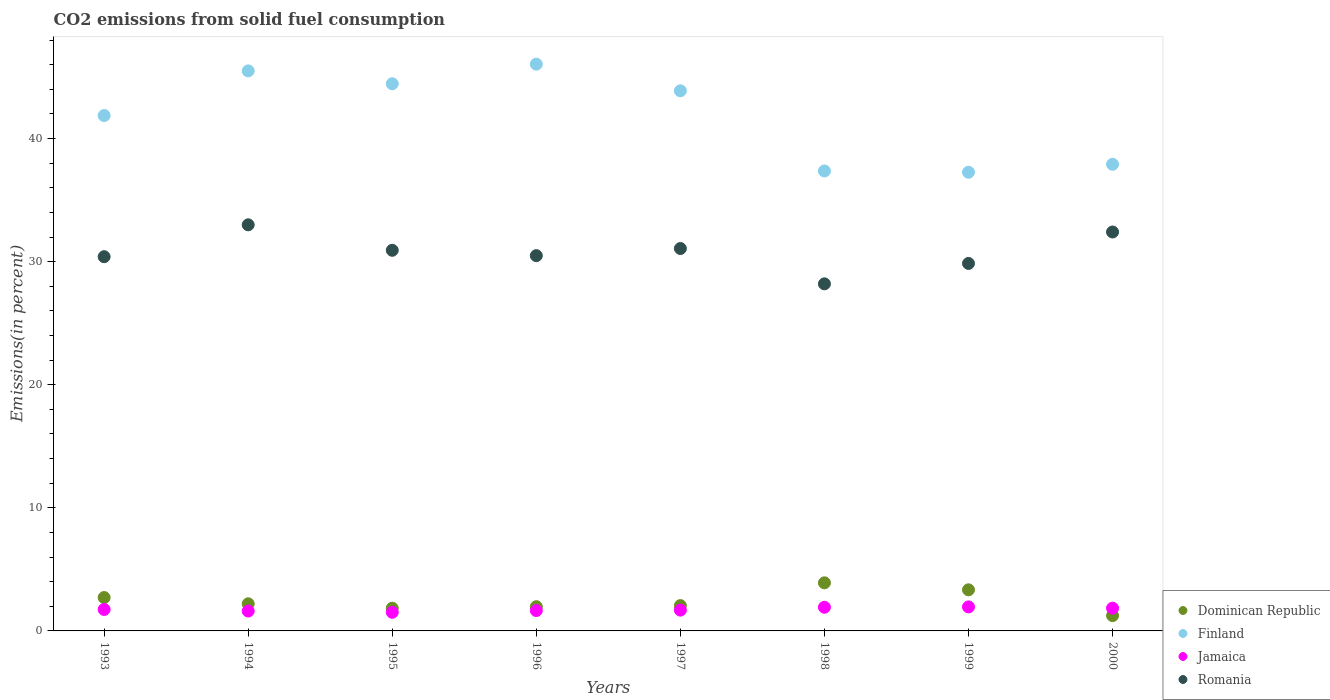What is the total CO2 emitted in Finland in 2000?
Keep it short and to the point. 37.91. Across all years, what is the maximum total CO2 emitted in Dominican Republic?
Your response must be concise. 3.91. Across all years, what is the minimum total CO2 emitted in Jamaica?
Offer a terse response. 1.51. In which year was the total CO2 emitted in Jamaica minimum?
Your answer should be compact. 1995. What is the total total CO2 emitted in Finland in the graph?
Your response must be concise. 334.29. What is the difference between the total CO2 emitted in Finland in 1994 and that in 1996?
Give a very brief answer. -0.55. What is the difference between the total CO2 emitted in Finland in 1993 and the total CO2 emitted in Romania in 1999?
Offer a terse response. 12.01. What is the average total CO2 emitted in Dominican Republic per year?
Provide a short and direct response. 2.41. In the year 1998, what is the difference between the total CO2 emitted in Finland and total CO2 emitted in Jamaica?
Your answer should be very brief. 35.44. In how many years, is the total CO2 emitted in Finland greater than 10 %?
Your response must be concise. 8. What is the ratio of the total CO2 emitted in Finland in 1993 to that in 2000?
Offer a very short reply. 1.1. What is the difference between the highest and the second highest total CO2 emitted in Jamaica?
Your response must be concise. 0.03. What is the difference between the highest and the lowest total CO2 emitted in Dominican Republic?
Your answer should be very brief. 2.67. In how many years, is the total CO2 emitted in Romania greater than the average total CO2 emitted in Romania taken over all years?
Offer a very short reply. 4. Is it the case that in every year, the sum of the total CO2 emitted in Jamaica and total CO2 emitted in Dominican Republic  is greater than the sum of total CO2 emitted in Finland and total CO2 emitted in Romania?
Provide a short and direct response. No. Does the total CO2 emitted in Jamaica monotonically increase over the years?
Provide a short and direct response. No. Is the total CO2 emitted in Jamaica strictly greater than the total CO2 emitted in Finland over the years?
Your answer should be very brief. No. Is the total CO2 emitted in Finland strictly less than the total CO2 emitted in Jamaica over the years?
Your answer should be compact. No. How many years are there in the graph?
Offer a terse response. 8. What is the difference between two consecutive major ticks on the Y-axis?
Keep it short and to the point. 10. Are the values on the major ticks of Y-axis written in scientific E-notation?
Give a very brief answer. No. Does the graph contain any zero values?
Ensure brevity in your answer.  No. Where does the legend appear in the graph?
Your answer should be compact. Bottom right. How many legend labels are there?
Your response must be concise. 4. How are the legend labels stacked?
Keep it short and to the point. Vertical. What is the title of the graph?
Ensure brevity in your answer.  CO2 emissions from solid fuel consumption. What is the label or title of the X-axis?
Offer a very short reply. Years. What is the label or title of the Y-axis?
Your answer should be compact. Emissions(in percent). What is the Emissions(in percent) of Dominican Republic in 1993?
Keep it short and to the point. 2.71. What is the Emissions(in percent) in Finland in 1993?
Offer a terse response. 41.87. What is the Emissions(in percent) of Jamaica in 1993?
Your response must be concise. 1.74. What is the Emissions(in percent) in Romania in 1993?
Provide a succinct answer. 30.4. What is the Emissions(in percent) in Dominican Republic in 1994?
Provide a short and direct response. 2.2. What is the Emissions(in percent) of Finland in 1994?
Your response must be concise. 45.5. What is the Emissions(in percent) in Jamaica in 1994?
Ensure brevity in your answer.  1.61. What is the Emissions(in percent) of Romania in 1994?
Offer a terse response. 32.99. What is the Emissions(in percent) of Dominican Republic in 1995?
Your answer should be very brief. 1.85. What is the Emissions(in percent) in Finland in 1995?
Provide a short and direct response. 44.45. What is the Emissions(in percent) in Jamaica in 1995?
Give a very brief answer. 1.51. What is the Emissions(in percent) in Romania in 1995?
Give a very brief answer. 30.92. What is the Emissions(in percent) of Dominican Republic in 1996?
Keep it short and to the point. 1.97. What is the Emissions(in percent) of Finland in 1996?
Keep it short and to the point. 46.04. What is the Emissions(in percent) of Jamaica in 1996?
Offer a terse response. 1.65. What is the Emissions(in percent) of Romania in 1996?
Your answer should be very brief. 30.49. What is the Emissions(in percent) in Dominican Republic in 1997?
Offer a very short reply. 2.06. What is the Emissions(in percent) in Finland in 1997?
Offer a terse response. 43.88. What is the Emissions(in percent) in Jamaica in 1997?
Make the answer very short. 1.69. What is the Emissions(in percent) in Romania in 1997?
Provide a succinct answer. 31.07. What is the Emissions(in percent) of Dominican Republic in 1998?
Your response must be concise. 3.91. What is the Emissions(in percent) in Finland in 1998?
Offer a terse response. 37.37. What is the Emissions(in percent) of Jamaica in 1998?
Offer a very short reply. 1.92. What is the Emissions(in percent) in Romania in 1998?
Your answer should be very brief. 28.2. What is the Emissions(in percent) in Dominican Republic in 1999?
Your answer should be very brief. 3.34. What is the Emissions(in percent) in Finland in 1999?
Keep it short and to the point. 37.26. What is the Emissions(in percent) in Jamaica in 1999?
Your response must be concise. 1.95. What is the Emissions(in percent) in Romania in 1999?
Your response must be concise. 29.85. What is the Emissions(in percent) in Dominican Republic in 2000?
Offer a very short reply. 1.24. What is the Emissions(in percent) of Finland in 2000?
Offer a very short reply. 37.91. What is the Emissions(in percent) of Jamaica in 2000?
Your response must be concise. 1.85. What is the Emissions(in percent) in Romania in 2000?
Your answer should be very brief. 32.41. Across all years, what is the maximum Emissions(in percent) in Dominican Republic?
Keep it short and to the point. 3.91. Across all years, what is the maximum Emissions(in percent) of Finland?
Ensure brevity in your answer.  46.04. Across all years, what is the maximum Emissions(in percent) in Jamaica?
Make the answer very short. 1.95. Across all years, what is the maximum Emissions(in percent) of Romania?
Make the answer very short. 32.99. Across all years, what is the minimum Emissions(in percent) of Dominican Republic?
Provide a succinct answer. 1.24. Across all years, what is the minimum Emissions(in percent) in Finland?
Your answer should be compact. 37.26. Across all years, what is the minimum Emissions(in percent) in Jamaica?
Give a very brief answer. 1.51. Across all years, what is the minimum Emissions(in percent) in Romania?
Ensure brevity in your answer.  28.2. What is the total Emissions(in percent) of Dominican Republic in the graph?
Provide a succinct answer. 19.28. What is the total Emissions(in percent) in Finland in the graph?
Your answer should be compact. 334.29. What is the total Emissions(in percent) in Jamaica in the graph?
Your answer should be very brief. 13.93. What is the total Emissions(in percent) of Romania in the graph?
Ensure brevity in your answer.  246.33. What is the difference between the Emissions(in percent) in Dominican Republic in 1993 and that in 1994?
Your answer should be compact. 0.51. What is the difference between the Emissions(in percent) in Finland in 1993 and that in 1994?
Provide a short and direct response. -3.63. What is the difference between the Emissions(in percent) in Jamaica in 1993 and that in 1994?
Offer a terse response. 0.13. What is the difference between the Emissions(in percent) in Romania in 1993 and that in 1994?
Ensure brevity in your answer.  -2.59. What is the difference between the Emissions(in percent) of Dominican Republic in 1993 and that in 1995?
Your answer should be compact. 0.87. What is the difference between the Emissions(in percent) in Finland in 1993 and that in 1995?
Offer a terse response. -2.58. What is the difference between the Emissions(in percent) in Jamaica in 1993 and that in 1995?
Make the answer very short. 0.23. What is the difference between the Emissions(in percent) of Romania in 1993 and that in 1995?
Provide a short and direct response. -0.52. What is the difference between the Emissions(in percent) in Dominican Republic in 1993 and that in 1996?
Make the answer very short. 0.74. What is the difference between the Emissions(in percent) in Finland in 1993 and that in 1996?
Give a very brief answer. -4.17. What is the difference between the Emissions(in percent) of Jamaica in 1993 and that in 1996?
Your response must be concise. 0.09. What is the difference between the Emissions(in percent) of Romania in 1993 and that in 1996?
Make the answer very short. -0.08. What is the difference between the Emissions(in percent) in Dominican Republic in 1993 and that in 1997?
Give a very brief answer. 0.65. What is the difference between the Emissions(in percent) of Finland in 1993 and that in 1997?
Give a very brief answer. -2.01. What is the difference between the Emissions(in percent) in Jamaica in 1993 and that in 1997?
Offer a terse response. 0.05. What is the difference between the Emissions(in percent) of Romania in 1993 and that in 1997?
Make the answer very short. -0.66. What is the difference between the Emissions(in percent) in Dominican Republic in 1993 and that in 1998?
Offer a very short reply. -1.19. What is the difference between the Emissions(in percent) in Finland in 1993 and that in 1998?
Your response must be concise. 4.5. What is the difference between the Emissions(in percent) of Jamaica in 1993 and that in 1998?
Provide a succinct answer. -0.18. What is the difference between the Emissions(in percent) of Romania in 1993 and that in 1998?
Make the answer very short. 2.21. What is the difference between the Emissions(in percent) of Dominican Republic in 1993 and that in 1999?
Provide a succinct answer. -0.63. What is the difference between the Emissions(in percent) of Finland in 1993 and that in 1999?
Give a very brief answer. 4.61. What is the difference between the Emissions(in percent) of Jamaica in 1993 and that in 1999?
Your answer should be very brief. -0.21. What is the difference between the Emissions(in percent) of Romania in 1993 and that in 1999?
Keep it short and to the point. 0.55. What is the difference between the Emissions(in percent) in Dominican Republic in 1993 and that in 2000?
Your answer should be very brief. 1.47. What is the difference between the Emissions(in percent) of Finland in 1993 and that in 2000?
Offer a terse response. 3.96. What is the difference between the Emissions(in percent) in Jamaica in 1993 and that in 2000?
Your answer should be compact. -0.1. What is the difference between the Emissions(in percent) in Romania in 1993 and that in 2000?
Give a very brief answer. -2.01. What is the difference between the Emissions(in percent) of Dominican Republic in 1994 and that in 1995?
Your answer should be compact. 0.36. What is the difference between the Emissions(in percent) of Finland in 1994 and that in 1995?
Your answer should be very brief. 1.05. What is the difference between the Emissions(in percent) of Jamaica in 1994 and that in 1995?
Offer a very short reply. 0.1. What is the difference between the Emissions(in percent) of Romania in 1994 and that in 1995?
Your response must be concise. 2.07. What is the difference between the Emissions(in percent) in Dominican Republic in 1994 and that in 1996?
Offer a very short reply. 0.24. What is the difference between the Emissions(in percent) of Finland in 1994 and that in 1996?
Keep it short and to the point. -0.55. What is the difference between the Emissions(in percent) in Jamaica in 1994 and that in 1996?
Your answer should be compact. -0.04. What is the difference between the Emissions(in percent) of Romania in 1994 and that in 1996?
Provide a succinct answer. 2.51. What is the difference between the Emissions(in percent) of Dominican Republic in 1994 and that in 1997?
Provide a succinct answer. 0.15. What is the difference between the Emissions(in percent) of Finland in 1994 and that in 1997?
Your response must be concise. 1.62. What is the difference between the Emissions(in percent) of Jamaica in 1994 and that in 1997?
Give a very brief answer. -0.08. What is the difference between the Emissions(in percent) of Romania in 1994 and that in 1997?
Your answer should be very brief. 1.93. What is the difference between the Emissions(in percent) in Dominican Republic in 1994 and that in 1998?
Provide a short and direct response. -1.7. What is the difference between the Emissions(in percent) of Finland in 1994 and that in 1998?
Your answer should be very brief. 8.13. What is the difference between the Emissions(in percent) in Jamaica in 1994 and that in 1998?
Your answer should be very brief. -0.31. What is the difference between the Emissions(in percent) in Romania in 1994 and that in 1998?
Make the answer very short. 4.8. What is the difference between the Emissions(in percent) of Dominican Republic in 1994 and that in 1999?
Keep it short and to the point. -1.13. What is the difference between the Emissions(in percent) of Finland in 1994 and that in 1999?
Your answer should be compact. 8.23. What is the difference between the Emissions(in percent) in Jamaica in 1994 and that in 1999?
Provide a succinct answer. -0.34. What is the difference between the Emissions(in percent) in Romania in 1994 and that in 1999?
Ensure brevity in your answer.  3.14. What is the difference between the Emissions(in percent) of Dominican Republic in 1994 and that in 2000?
Your response must be concise. 0.96. What is the difference between the Emissions(in percent) of Finland in 1994 and that in 2000?
Offer a very short reply. 7.59. What is the difference between the Emissions(in percent) in Jamaica in 1994 and that in 2000?
Make the answer very short. -0.23. What is the difference between the Emissions(in percent) of Romania in 1994 and that in 2000?
Provide a short and direct response. 0.58. What is the difference between the Emissions(in percent) of Dominican Republic in 1995 and that in 1996?
Provide a short and direct response. -0.12. What is the difference between the Emissions(in percent) of Finland in 1995 and that in 1996?
Offer a terse response. -1.59. What is the difference between the Emissions(in percent) of Jamaica in 1995 and that in 1996?
Give a very brief answer. -0.14. What is the difference between the Emissions(in percent) of Romania in 1995 and that in 1996?
Offer a very short reply. 0.44. What is the difference between the Emissions(in percent) in Dominican Republic in 1995 and that in 1997?
Your response must be concise. -0.21. What is the difference between the Emissions(in percent) of Finland in 1995 and that in 1997?
Offer a very short reply. 0.57. What is the difference between the Emissions(in percent) in Jamaica in 1995 and that in 1997?
Offer a terse response. -0.18. What is the difference between the Emissions(in percent) of Romania in 1995 and that in 1997?
Your answer should be very brief. -0.14. What is the difference between the Emissions(in percent) in Dominican Republic in 1995 and that in 1998?
Give a very brief answer. -2.06. What is the difference between the Emissions(in percent) of Finland in 1995 and that in 1998?
Provide a short and direct response. 7.09. What is the difference between the Emissions(in percent) in Jamaica in 1995 and that in 1998?
Offer a terse response. -0.41. What is the difference between the Emissions(in percent) in Romania in 1995 and that in 1998?
Offer a very short reply. 2.73. What is the difference between the Emissions(in percent) of Dominican Republic in 1995 and that in 1999?
Ensure brevity in your answer.  -1.49. What is the difference between the Emissions(in percent) of Finland in 1995 and that in 1999?
Offer a very short reply. 7.19. What is the difference between the Emissions(in percent) of Jamaica in 1995 and that in 1999?
Make the answer very short. -0.44. What is the difference between the Emissions(in percent) of Romania in 1995 and that in 1999?
Your response must be concise. 1.07. What is the difference between the Emissions(in percent) in Dominican Republic in 1995 and that in 2000?
Keep it short and to the point. 0.61. What is the difference between the Emissions(in percent) in Finland in 1995 and that in 2000?
Ensure brevity in your answer.  6.54. What is the difference between the Emissions(in percent) of Jamaica in 1995 and that in 2000?
Ensure brevity in your answer.  -0.34. What is the difference between the Emissions(in percent) in Romania in 1995 and that in 2000?
Your response must be concise. -1.49. What is the difference between the Emissions(in percent) in Dominican Republic in 1996 and that in 1997?
Offer a terse response. -0.09. What is the difference between the Emissions(in percent) in Finland in 1996 and that in 1997?
Provide a succinct answer. 2.16. What is the difference between the Emissions(in percent) in Jamaica in 1996 and that in 1997?
Give a very brief answer. -0.04. What is the difference between the Emissions(in percent) in Romania in 1996 and that in 1997?
Provide a short and direct response. -0.58. What is the difference between the Emissions(in percent) of Dominican Republic in 1996 and that in 1998?
Ensure brevity in your answer.  -1.94. What is the difference between the Emissions(in percent) of Finland in 1996 and that in 1998?
Give a very brief answer. 8.68. What is the difference between the Emissions(in percent) in Jamaica in 1996 and that in 1998?
Provide a succinct answer. -0.27. What is the difference between the Emissions(in percent) of Romania in 1996 and that in 1998?
Provide a succinct answer. 2.29. What is the difference between the Emissions(in percent) of Dominican Republic in 1996 and that in 1999?
Keep it short and to the point. -1.37. What is the difference between the Emissions(in percent) of Finland in 1996 and that in 1999?
Keep it short and to the point. 8.78. What is the difference between the Emissions(in percent) of Jamaica in 1996 and that in 1999?
Ensure brevity in your answer.  -0.3. What is the difference between the Emissions(in percent) of Romania in 1996 and that in 1999?
Keep it short and to the point. 0.63. What is the difference between the Emissions(in percent) in Dominican Republic in 1996 and that in 2000?
Provide a short and direct response. 0.73. What is the difference between the Emissions(in percent) of Finland in 1996 and that in 2000?
Keep it short and to the point. 8.13. What is the difference between the Emissions(in percent) in Jamaica in 1996 and that in 2000?
Offer a very short reply. -0.19. What is the difference between the Emissions(in percent) in Romania in 1996 and that in 2000?
Offer a very short reply. -1.92. What is the difference between the Emissions(in percent) in Dominican Republic in 1997 and that in 1998?
Provide a short and direct response. -1.85. What is the difference between the Emissions(in percent) in Finland in 1997 and that in 1998?
Your answer should be very brief. 6.52. What is the difference between the Emissions(in percent) in Jamaica in 1997 and that in 1998?
Provide a succinct answer. -0.23. What is the difference between the Emissions(in percent) of Romania in 1997 and that in 1998?
Provide a succinct answer. 2.87. What is the difference between the Emissions(in percent) of Dominican Republic in 1997 and that in 1999?
Keep it short and to the point. -1.28. What is the difference between the Emissions(in percent) of Finland in 1997 and that in 1999?
Offer a terse response. 6.62. What is the difference between the Emissions(in percent) in Jamaica in 1997 and that in 1999?
Offer a terse response. -0.26. What is the difference between the Emissions(in percent) of Romania in 1997 and that in 1999?
Your answer should be very brief. 1.21. What is the difference between the Emissions(in percent) of Dominican Republic in 1997 and that in 2000?
Keep it short and to the point. 0.82. What is the difference between the Emissions(in percent) of Finland in 1997 and that in 2000?
Keep it short and to the point. 5.97. What is the difference between the Emissions(in percent) of Jamaica in 1997 and that in 2000?
Your answer should be compact. -0.16. What is the difference between the Emissions(in percent) of Romania in 1997 and that in 2000?
Provide a succinct answer. -1.34. What is the difference between the Emissions(in percent) in Dominican Republic in 1998 and that in 1999?
Provide a succinct answer. 0.57. What is the difference between the Emissions(in percent) in Finland in 1998 and that in 1999?
Your answer should be compact. 0.1. What is the difference between the Emissions(in percent) in Jamaica in 1998 and that in 1999?
Make the answer very short. -0.03. What is the difference between the Emissions(in percent) in Romania in 1998 and that in 1999?
Provide a short and direct response. -1.66. What is the difference between the Emissions(in percent) in Dominican Republic in 1998 and that in 2000?
Ensure brevity in your answer.  2.67. What is the difference between the Emissions(in percent) in Finland in 1998 and that in 2000?
Your answer should be compact. -0.54. What is the difference between the Emissions(in percent) of Jamaica in 1998 and that in 2000?
Your response must be concise. 0.07. What is the difference between the Emissions(in percent) in Romania in 1998 and that in 2000?
Your answer should be compact. -4.21. What is the difference between the Emissions(in percent) of Dominican Republic in 1999 and that in 2000?
Provide a short and direct response. 2.1. What is the difference between the Emissions(in percent) in Finland in 1999 and that in 2000?
Make the answer very short. -0.65. What is the difference between the Emissions(in percent) of Jamaica in 1999 and that in 2000?
Provide a succinct answer. 0.1. What is the difference between the Emissions(in percent) in Romania in 1999 and that in 2000?
Your answer should be compact. -2.55. What is the difference between the Emissions(in percent) in Dominican Republic in 1993 and the Emissions(in percent) in Finland in 1994?
Your answer should be very brief. -42.79. What is the difference between the Emissions(in percent) of Dominican Republic in 1993 and the Emissions(in percent) of Jamaica in 1994?
Provide a succinct answer. 1.1. What is the difference between the Emissions(in percent) in Dominican Republic in 1993 and the Emissions(in percent) in Romania in 1994?
Offer a terse response. -30.28. What is the difference between the Emissions(in percent) of Finland in 1993 and the Emissions(in percent) of Jamaica in 1994?
Keep it short and to the point. 40.26. What is the difference between the Emissions(in percent) of Finland in 1993 and the Emissions(in percent) of Romania in 1994?
Provide a succinct answer. 8.88. What is the difference between the Emissions(in percent) in Jamaica in 1993 and the Emissions(in percent) in Romania in 1994?
Your answer should be compact. -31.25. What is the difference between the Emissions(in percent) of Dominican Republic in 1993 and the Emissions(in percent) of Finland in 1995?
Provide a short and direct response. -41.74. What is the difference between the Emissions(in percent) in Dominican Republic in 1993 and the Emissions(in percent) in Jamaica in 1995?
Ensure brevity in your answer.  1.2. What is the difference between the Emissions(in percent) in Dominican Republic in 1993 and the Emissions(in percent) in Romania in 1995?
Make the answer very short. -28.21. What is the difference between the Emissions(in percent) in Finland in 1993 and the Emissions(in percent) in Jamaica in 1995?
Offer a terse response. 40.36. What is the difference between the Emissions(in percent) of Finland in 1993 and the Emissions(in percent) of Romania in 1995?
Your answer should be compact. 10.95. What is the difference between the Emissions(in percent) in Jamaica in 1993 and the Emissions(in percent) in Romania in 1995?
Your response must be concise. -29.18. What is the difference between the Emissions(in percent) in Dominican Republic in 1993 and the Emissions(in percent) in Finland in 1996?
Your answer should be very brief. -43.33. What is the difference between the Emissions(in percent) in Dominican Republic in 1993 and the Emissions(in percent) in Jamaica in 1996?
Make the answer very short. 1.06. What is the difference between the Emissions(in percent) in Dominican Republic in 1993 and the Emissions(in percent) in Romania in 1996?
Offer a terse response. -27.78. What is the difference between the Emissions(in percent) in Finland in 1993 and the Emissions(in percent) in Jamaica in 1996?
Keep it short and to the point. 40.22. What is the difference between the Emissions(in percent) in Finland in 1993 and the Emissions(in percent) in Romania in 1996?
Your answer should be very brief. 11.38. What is the difference between the Emissions(in percent) of Jamaica in 1993 and the Emissions(in percent) of Romania in 1996?
Your answer should be very brief. -28.74. What is the difference between the Emissions(in percent) in Dominican Republic in 1993 and the Emissions(in percent) in Finland in 1997?
Keep it short and to the point. -41.17. What is the difference between the Emissions(in percent) of Dominican Republic in 1993 and the Emissions(in percent) of Jamaica in 1997?
Ensure brevity in your answer.  1.02. What is the difference between the Emissions(in percent) of Dominican Republic in 1993 and the Emissions(in percent) of Romania in 1997?
Provide a succinct answer. -28.36. What is the difference between the Emissions(in percent) of Finland in 1993 and the Emissions(in percent) of Jamaica in 1997?
Your answer should be compact. 40.18. What is the difference between the Emissions(in percent) in Finland in 1993 and the Emissions(in percent) in Romania in 1997?
Keep it short and to the point. 10.8. What is the difference between the Emissions(in percent) of Jamaica in 1993 and the Emissions(in percent) of Romania in 1997?
Offer a very short reply. -29.32. What is the difference between the Emissions(in percent) of Dominican Republic in 1993 and the Emissions(in percent) of Finland in 1998?
Make the answer very short. -34.65. What is the difference between the Emissions(in percent) in Dominican Republic in 1993 and the Emissions(in percent) in Jamaica in 1998?
Give a very brief answer. 0.79. What is the difference between the Emissions(in percent) of Dominican Republic in 1993 and the Emissions(in percent) of Romania in 1998?
Give a very brief answer. -25.48. What is the difference between the Emissions(in percent) of Finland in 1993 and the Emissions(in percent) of Jamaica in 1998?
Offer a very short reply. 39.95. What is the difference between the Emissions(in percent) in Finland in 1993 and the Emissions(in percent) in Romania in 1998?
Make the answer very short. 13.67. What is the difference between the Emissions(in percent) in Jamaica in 1993 and the Emissions(in percent) in Romania in 1998?
Provide a short and direct response. -26.45. What is the difference between the Emissions(in percent) of Dominican Republic in 1993 and the Emissions(in percent) of Finland in 1999?
Your answer should be compact. -34.55. What is the difference between the Emissions(in percent) in Dominican Republic in 1993 and the Emissions(in percent) in Jamaica in 1999?
Keep it short and to the point. 0.76. What is the difference between the Emissions(in percent) in Dominican Republic in 1993 and the Emissions(in percent) in Romania in 1999?
Keep it short and to the point. -27.14. What is the difference between the Emissions(in percent) in Finland in 1993 and the Emissions(in percent) in Jamaica in 1999?
Give a very brief answer. 39.92. What is the difference between the Emissions(in percent) of Finland in 1993 and the Emissions(in percent) of Romania in 1999?
Your answer should be compact. 12.02. What is the difference between the Emissions(in percent) in Jamaica in 1993 and the Emissions(in percent) in Romania in 1999?
Give a very brief answer. -28.11. What is the difference between the Emissions(in percent) of Dominican Republic in 1993 and the Emissions(in percent) of Finland in 2000?
Make the answer very short. -35.2. What is the difference between the Emissions(in percent) in Dominican Republic in 1993 and the Emissions(in percent) in Jamaica in 2000?
Offer a very short reply. 0.86. What is the difference between the Emissions(in percent) in Dominican Republic in 1993 and the Emissions(in percent) in Romania in 2000?
Give a very brief answer. -29.7. What is the difference between the Emissions(in percent) of Finland in 1993 and the Emissions(in percent) of Jamaica in 2000?
Your answer should be very brief. 40.02. What is the difference between the Emissions(in percent) of Finland in 1993 and the Emissions(in percent) of Romania in 2000?
Your response must be concise. 9.46. What is the difference between the Emissions(in percent) of Jamaica in 1993 and the Emissions(in percent) of Romania in 2000?
Keep it short and to the point. -30.67. What is the difference between the Emissions(in percent) in Dominican Republic in 1994 and the Emissions(in percent) in Finland in 1995?
Ensure brevity in your answer.  -42.25. What is the difference between the Emissions(in percent) of Dominican Republic in 1994 and the Emissions(in percent) of Jamaica in 1995?
Offer a very short reply. 0.69. What is the difference between the Emissions(in percent) of Dominican Republic in 1994 and the Emissions(in percent) of Romania in 1995?
Offer a very short reply. -28.72. What is the difference between the Emissions(in percent) in Finland in 1994 and the Emissions(in percent) in Jamaica in 1995?
Ensure brevity in your answer.  43.99. What is the difference between the Emissions(in percent) in Finland in 1994 and the Emissions(in percent) in Romania in 1995?
Your answer should be compact. 14.58. What is the difference between the Emissions(in percent) in Jamaica in 1994 and the Emissions(in percent) in Romania in 1995?
Offer a very short reply. -29.31. What is the difference between the Emissions(in percent) in Dominican Republic in 1994 and the Emissions(in percent) in Finland in 1996?
Ensure brevity in your answer.  -43.84. What is the difference between the Emissions(in percent) of Dominican Republic in 1994 and the Emissions(in percent) of Jamaica in 1996?
Keep it short and to the point. 0.55. What is the difference between the Emissions(in percent) of Dominican Republic in 1994 and the Emissions(in percent) of Romania in 1996?
Your response must be concise. -28.28. What is the difference between the Emissions(in percent) in Finland in 1994 and the Emissions(in percent) in Jamaica in 1996?
Your answer should be compact. 43.84. What is the difference between the Emissions(in percent) in Finland in 1994 and the Emissions(in percent) in Romania in 1996?
Offer a very short reply. 15.01. What is the difference between the Emissions(in percent) of Jamaica in 1994 and the Emissions(in percent) of Romania in 1996?
Provide a succinct answer. -28.87. What is the difference between the Emissions(in percent) of Dominican Republic in 1994 and the Emissions(in percent) of Finland in 1997?
Your answer should be compact. -41.68. What is the difference between the Emissions(in percent) of Dominican Republic in 1994 and the Emissions(in percent) of Jamaica in 1997?
Your answer should be very brief. 0.51. What is the difference between the Emissions(in percent) of Dominican Republic in 1994 and the Emissions(in percent) of Romania in 1997?
Provide a succinct answer. -28.86. What is the difference between the Emissions(in percent) in Finland in 1994 and the Emissions(in percent) in Jamaica in 1997?
Offer a terse response. 43.81. What is the difference between the Emissions(in percent) of Finland in 1994 and the Emissions(in percent) of Romania in 1997?
Make the answer very short. 14.43. What is the difference between the Emissions(in percent) of Jamaica in 1994 and the Emissions(in percent) of Romania in 1997?
Your response must be concise. -29.45. What is the difference between the Emissions(in percent) in Dominican Republic in 1994 and the Emissions(in percent) in Finland in 1998?
Make the answer very short. -35.16. What is the difference between the Emissions(in percent) in Dominican Republic in 1994 and the Emissions(in percent) in Jamaica in 1998?
Ensure brevity in your answer.  0.28. What is the difference between the Emissions(in percent) of Dominican Republic in 1994 and the Emissions(in percent) of Romania in 1998?
Give a very brief answer. -25.99. What is the difference between the Emissions(in percent) in Finland in 1994 and the Emissions(in percent) in Jamaica in 1998?
Your answer should be very brief. 43.58. What is the difference between the Emissions(in percent) in Finland in 1994 and the Emissions(in percent) in Romania in 1998?
Make the answer very short. 17.3. What is the difference between the Emissions(in percent) of Jamaica in 1994 and the Emissions(in percent) of Romania in 1998?
Keep it short and to the point. -26.58. What is the difference between the Emissions(in percent) in Dominican Republic in 1994 and the Emissions(in percent) in Finland in 1999?
Make the answer very short. -35.06. What is the difference between the Emissions(in percent) in Dominican Republic in 1994 and the Emissions(in percent) in Jamaica in 1999?
Your answer should be very brief. 0.25. What is the difference between the Emissions(in percent) of Dominican Republic in 1994 and the Emissions(in percent) of Romania in 1999?
Keep it short and to the point. -27.65. What is the difference between the Emissions(in percent) in Finland in 1994 and the Emissions(in percent) in Jamaica in 1999?
Offer a terse response. 43.55. What is the difference between the Emissions(in percent) of Finland in 1994 and the Emissions(in percent) of Romania in 1999?
Keep it short and to the point. 15.64. What is the difference between the Emissions(in percent) of Jamaica in 1994 and the Emissions(in percent) of Romania in 1999?
Provide a short and direct response. -28.24. What is the difference between the Emissions(in percent) of Dominican Republic in 1994 and the Emissions(in percent) of Finland in 2000?
Offer a terse response. -35.71. What is the difference between the Emissions(in percent) of Dominican Republic in 1994 and the Emissions(in percent) of Jamaica in 2000?
Give a very brief answer. 0.36. What is the difference between the Emissions(in percent) of Dominican Republic in 1994 and the Emissions(in percent) of Romania in 2000?
Your answer should be very brief. -30.2. What is the difference between the Emissions(in percent) of Finland in 1994 and the Emissions(in percent) of Jamaica in 2000?
Provide a succinct answer. 43.65. What is the difference between the Emissions(in percent) in Finland in 1994 and the Emissions(in percent) in Romania in 2000?
Offer a terse response. 13.09. What is the difference between the Emissions(in percent) in Jamaica in 1994 and the Emissions(in percent) in Romania in 2000?
Your answer should be compact. -30.8. What is the difference between the Emissions(in percent) of Dominican Republic in 1995 and the Emissions(in percent) of Finland in 1996?
Provide a succinct answer. -44.2. What is the difference between the Emissions(in percent) in Dominican Republic in 1995 and the Emissions(in percent) in Jamaica in 1996?
Ensure brevity in your answer.  0.19. What is the difference between the Emissions(in percent) of Dominican Republic in 1995 and the Emissions(in percent) of Romania in 1996?
Ensure brevity in your answer.  -28.64. What is the difference between the Emissions(in percent) of Finland in 1995 and the Emissions(in percent) of Jamaica in 1996?
Offer a terse response. 42.8. What is the difference between the Emissions(in percent) of Finland in 1995 and the Emissions(in percent) of Romania in 1996?
Keep it short and to the point. 13.96. What is the difference between the Emissions(in percent) of Jamaica in 1995 and the Emissions(in percent) of Romania in 1996?
Your answer should be very brief. -28.98. What is the difference between the Emissions(in percent) in Dominican Republic in 1995 and the Emissions(in percent) in Finland in 1997?
Ensure brevity in your answer.  -42.03. What is the difference between the Emissions(in percent) of Dominican Republic in 1995 and the Emissions(in percent) of Jamaica in 1997?
Offer a very short reply. 0.16. What is the difference between the Emissions(in percent) of Dominican Republic in 1995 and the Emissions(in percent) of Romania in 1997?
Your response must be concise. -29.22. What is the difference between the Emissions(in percent) of Finland in 1995 and the Emissions(in percent) of Jamaica in 1997?
Offer a terse response. 42.76. What is the difference between the Emissions(in percent) of Finland in 1995 and the Emissions(in percent) of Romania in 1997?
Your answer should be compact. 13.39. What is the difference between the Emissions(in percent) of Jamaica in 1995 and the Emissions(in percent) of Romania in 1997?
Your answer should be compact. -29.56. What is the difference between the Emissions(in percent) of Dominican Republic in 1995 and the Emissions(in percent) of Finland in 1998?
Your response must be concise. -35.52. What is the difference between the Emissions(in percent) of Dominican Republic in 1995 and the Emissions(in percent) of Jamaica in 1998?
Your answer should be compact. -0.08. What is the difference between the Emissions(in percent) of Dominican Republic in 1995 and the Emissions(in percent) of Romania in 1998?
Make the answer very short. -26.35. What is the difference between the Emissions(in percent) of Finland in 1995 and the Emissions(in percent) of Jamaica in 1998?
Keep it short and to the point. 42.53. What is the difference between the Emissions(in percent) in Finland in 1995 and the Emissions(in percent) in Romania in 1998?
Your response must be concise. 16.26. What is the difference between the Emissions(in percent) in Jamaica in 1995 and the Emissions(in percent) in Romania in 1998?
Keep it short and to the point. -26.69. What is the difference between the Emissions(in percent) of Dominican Republic in 1995 and the Emissions(in percent) of Finland in 1999?
Provide a short and direct response. -35.42. What is the difference between the Emissions(in percent) in Dominican Republic in 1995 and the Emissions(in percent) in Jamaica in 1999?
Give a very brief answer. -0.1. What is the difference between the Emissions(in percent) in Dominican Republic in 1995 and the Emissions(in percent) in Romania in 1999?
Offer a very short reply. -28.01. What is the difference between the Emissions(in percent) of Finland in 1995 and the Emissions(in percent) of Jamaica in 1999?
Offer a very short reply. 42.5. What is the difference between the Emissions(in percent) in Finland in 1995 and the Emissions(in percent) in Romania in 1999?
Keep it short and to the point. 14.6. What is the difference between the Emissions(in percent) in Jamaica in 1995 and the Emissions(in percent) in Romania in 1999?
Give a very brief answer. -28.34. What is the difference between the Emissions(in percent) of Dominican Republic in 1995 and the Emissions(in percent) of Finland in 2000?
Provide a short and direct response. -36.06. What is the difference between the Emissions(in percent) in Dominican Republic in 1995 and the Emissions(in percent) in Jamaica in 2000?
Provide a short and direct response. -0. What is the difference between the Emissions(in percent) of Dominican Republic in 1995 and the Emissions(in percent) of Romania in 2000?
Keep it short and to the point. -30.56. What is the difference between the Emissions(in percent) of Finland in 1995 and the Emissions(in percent) of Jamaica in 2000?
Ensure brevity in your answer.  42.6. What is the difference between the Emissions(in percent) of Finland in 1995 and the Emissions(in percent) of Romania in 2000?
Provide a short and direct response. 12.04. What is the difference between the Emissions(in percent) of Jamaica in 1995 and the Emissions(in percent) of Romania in 2000?
Give a very brief answer. -30.9. What is the difference between the Emissions(in percent) of Dominican Republic in 1996 and the Emissions(in percent) of Finland in 1997?
Your answer should be very brief. -41.91. What is the difference between the Emissions(in percent) in Dominican Republic in 1996 and the Emissions(in percent) in Jamaica in 1997?
Your answer should be compact. 0.28. What is the difference between the Emissions(in percent) of Dominican Republic in 1996 and the Emissions(in percent) of Romania in 1997?
Make the answer very short. -29.1. What is the difference between the Emissions(in percent) in Finland in 1996 and the Emissions(in percent) in Jamaica in 1997?
Your response must be concise. 44.35. What is the difference between the Emissions(in percent) in Finland in 1996 and the Emissions(in percent) in Romania in 1997?
Offer a terse response. 14.98. What is the difference between the Emissions(in percent) of Jamaica in 1996 and the Emissions(in percent) of Romania in 1997?
Ensure brevity in your answer.  -29.41. What is the difference between the Emissions(in percent) of Dominican Republic in 1996 and the Emissions(in percent) of Finland in 1998?
Offer a terse response. -35.4. What is the difference between the Emissions(in percent) in Dominican Republic in 1996 and the Emissions(in percent) in Jamaica in 1998?
Your response must be concise. 0.05. What is the difference between the Emissions(in percent) in Dominican Republic in 1996 and the Emissions(in percent) in Romania in 1998?
Give a very brief answer. -26.23. What is the difference between the Emissions(in percent) in Finland in 1996 and the Emissions(in percent) in Jamaica in 1998?
Offer a terse response. 44.12. What is the difference between the Emissions(in percent) in Finland in 1996 and the Emissions(in percent) in Romania in 1998?
Your response must be concise. 17.85. What is the difference between the Emissions(in percent) of Jamaica in 1996 and the Emissions(in percent) of Romania in 1998?
Provide a short and direct response. -26.54. What is the difference between the Emissions(in percent) of Dominican Republic in 1996 and the Emissions(in percent) of Finland in 1999?
Give a very brief answer. -35.3. What is the difference between the Emissions(in percent) of Dominican Republic in 1996 and the Emissions(in percent) of Jamaica in 1999?
Ensure brevity in your answer.  0.02. What is the difference between the Emissions(in percent) of Dominican Republic in 1996 and the Emissions(in percent) of Romania in 1999?
Provide a short and direct response. -27.89. What is the difference between the Emissions(in percent) in Finland in 1996 and the Emissions(in percent) in Jamaica in 1999?
Ensure brevity in your answer.  44.09. What is the difference between the Emissions(in percent) in Finland in 1996 and the Emissions(in percent) in Romania in 1999?
Ensure brevity in your answer.  16.19. What is the difference between the Emissions(in percent) of Jamaica in 1996 and the Emissions(in percent) of Romania in 1999?
Make the answer very short. -28.2. What is the difference between the Emissions(in percent) in Dominican Republic in 1996 and the Emissions(in percent) in Finland in 2000?
Your answer should be very brief. -35.94. What is the difference between the Emissions(in percent) in Dominican Republic in 1996 and the Emissions(in percent) in Jamaica in 2000?
Provide a short and direct response. 0.12. What is the difference between the Emissions(in percent) in Dominican Republic in 1996 and the Emissions(in percent) in Romania in 2000?
Your answer should be compact. -30.44. What is the difference between the Emissions(in percent) of Finland in 1996 and the Emissions(in percent) of Jamaica in 2000?
Provide a short and direct response. 44.2. What is the difference between the Emissions(in percent) of Finland in 1996 and the Emissions(in percent) of Romania in 2000?
Ensure brevity in your answer.  13.64. What is the difference between the Emissions(in percent) in Jamaica in 1996 and the Emissions(in percent) in Romania in 2000?
Your response must be concise. -30.76. What is the difference between the Emissions(in percent) of Dominican Republic in 1997 and the Emissions(in percent) of Finland in 1998?
Your response must be concise. -35.31. What is the difference between the Emissions(in percent) in Dominican Republic in 1997 and the Emissions(in percent) in Jamaica in 1998?
Your response must be concise. 0.14. What is the difference between the Emissions(in percent) of Dominican Republic in 1997 and the Emissions(in percent) of Romania in 1998?
Provide a succinct answer. -26.14. What is the difference between the Emissions(in percent) of Finland in 1997 and the Emissions(in percent) of Jamaica in 1998?
Your response must be concise. 41.96. What is the difference between the Emissions(in percent) of Finland in 1997 and the Emissions(in percent) of Romania in 1998?
Provide a succinct answer. 15.68. What is the difference between the Emissions(in percent) of Jamaica in 1997 and the Emissions(in percent) of Romania in 1998?
Keep it short and to the point. -26.51. What is the difference between the Emissions(in percent) of Dominican Republic in 1997 and the Emissions(in percent) of Finland in 1999?
Keep it short and to the point. -35.21. What is the difference between the Emissions(in percent) of Dominican Republic in 1997 and the Emissions(in percent) of Jamaica in 1999?
Provide a short and direct response. 0.11. What is the difference between the Emissions(in percent) in Dominican Republic in 1997 and the Emissions(in percent) in Romania in 1999?
Your response must be concise. -27.8. What is the difference between the Emissions(in percent) in Finland in 1997 and the Emissions(in percent) in Jamaica in 1999?
Provide a succinct answer. 41.93. What is the difference between the Emissions(in percent) of Finland in 1997 and the Emissions(in percent) of Romania in 1999?
Your answer should be compact. 14.03. What is the difference between the Emissions(in percent) in Jamaica in 1997 and the Emissions(in percent) in Romania in 1999?
Provide a succinct answer. -28.16. What is the difference between the Emissions(in percent) of Dominican Republic in 1997 and the Emissions(in percent) of Finland in 2000?
Your answer should be very brief. -35.85. What is the difference between the Emissions(in percent) of Dominican Republic in 1997 and the Emissions(in percent) of Jamaica in 2000?
Your answer should be compact. 0.21. What is the difference between the Emissions(in percent) of Dominican Republic in 1997 and the Emissions(in percent) of Romania in 2000?
Give a very brief answer. -30.35. What is the difference between the Emissions(in percent) of Finland in 1997 and the Emissions(in percent) of Jamaica in 2000?
Ensure brevity in your answer.  42.03. What is the difference between the Emissions(in percent) of Finland in 1997 and the Emissions(in percent) of Romania in 2000?
Your response must be concise. 11.47. What is the difference between the Emissions(in percent) of Jamaica in 1997 and the Emissions(in percent) of Romania in 2000?
Your answer should be compact. -30.72. What is the difference between the Emissions(in percent) in Dominican Republic in 1998 and the Emissions(in percent) in Finland in 1999?
Your answer should be compact. -33.36. What is the difference between the Emissions(in percent) of Dominican Republic in 1998 and the Emissions(in percent) of Jamaica in 1999?
Provide a succinct answer. 1.96. What is the difference between the Emissions(in percent) of Dominican Republic in 1998 and the Emissions(in percent) of Romania in 1999?
Provide a short and direct response. -25.95. What is the difference between the Emissions(in percent) of Finland in 1998 and the Emissions(in percent) of Jamaica in 1999?
Your answer should be compact. 35.41. What is the difference between the Emissions(in percent) in Finland in 1998 and the Emissions(in percent) in Romania in 1999?
Your response must be concise. 7.51. What is the difference between the Emissions(in percent) in Jamaica in 1998 and the Emissions(in percent) in Romania in 1999?
Ensure brevity in your answer.  -27.93. What is the difference between the Emissions(in percent) in Dominican Republic in 1998 and the Emissions(in percent) in Finland in 2000?
Give a very brief answer. -34. What is the difference between the Emissions(in percent) in Dominican Republic in 1998 and the Emissions(in percent) in Jamaica in 2000?
Provide a succinct answer. 2.06. What is the difference between the Emissions(in percent) of Dominican Republic in 1998 and the Emissions(in percent) of Romania in 2000?
Offer a terse response. -28.5. What is the difference between the Emissions(in percent) of Finland in 1998 and the Emissions(in percent) of Jamaica in 2000?
Offer a very short reply. 35.52. What is the difference between the Emissions(in percent) of Finland in 1998 and the Emissions(in percent) of Romania in 2000?
Your answer should be very brief. 4.96. What is the difference between the Emissions(in percent) in Jamaica in 1998 and the Emissions(in percent) in Romania in 2000?
Keep it short and to the point. -30.49. What is the difference between the Emissions(in percent) in Dominican Republic in 1999 and the Emissions(in percent) in Finland in 2000?
Your answer should be compact. -34.57. What is the difference between the Emissions(in percent) of Dominican Republic in 1999 and the Emissions(in percent) of Jamaica in 2000?
Your answer should be very brief. 1.49. What is the difference between the Emissions(in percent) in Dominican Republic in 1999 and the Emissions(in percent) in Romania in 2000?
Your answer should be compact. -29.07. What is the difference between the Emissions(in percent) of Finland in 1999 and the Emissions(in percent) of Jamaica in 2000?
Keep it short and to the point. 35.42. What is the difference between the Emissions(in percent) of Finland in 1999 and the Emissions(in percent) of Romania in 2000?
Give a very brief answer. 4.85. What is the difference between the Emissions(in percent) of Jamaica in 1999 and the Emissions(in percent) of Romania in 2000?
Give a very brief answer. -30.46. What is the average Emissions(in percent) of Dominican Republic per year?
Ensure brevity in your answer.  2.41. What is the average Emissions(in percent) of Finland per year?
Give a very brief answer. 41.79. What is the average Emissions(in percent) in Jamaica per year?
Keep it short and to the point. 1.74. What is the average Emissions(in percent) in Romania per year?
Offer a very short reply. 30.79. In the year 1993, what is the difference between the Emissions(in percent) in Dominican Republic and Emissions(in percent) in Finland?
Keep it short and to the point. -39.16. In the year 1993, what is the difference between the Emissions(in percent) in Dominican Republic and Emissions(in percent) in Jamaica?
Give a very brief answer. 0.97. In the year 1993, what is the difference between the Emissions(in percent) of Dominican Republic and Emissions(in percent) of Romania?
Provide a short and direct response. -27.69. In the year 1993, what is the difference between the Emissions(in percent) in Finland and Emissions(in percent) in Jamaica?
Your answer should be compact. 40.13. In the year 1993, what is the difference between the Emissions(in percent) in Finland and Emissions(in percent) in Romania?
Offer a very short reply. 11.47. In the year 1993, what is the difference between the Emissions(in percent) of Jamaica and Emissions(in percent) of Romania?
Offer a very short reply. -28.66. In the year 1994, what is the difference between the Emissions(in percent) of Dominican Republic and Emissions(in percent) of Finland?
Offer a terse response. -43.29. In the year 1994, what is the difference between the Emissions(in percent) of Dominican Republic and Emissions(in percent) of Jamaica?
Provide a short and direct response. 0.59. In the year 1994, what is the difference between the Emissions(in percent) in Dominican Republic and Emissions(in percent) in Romania?
Give a very brief answer. -30.79. In the year 1994, what is the difference between the Emissions(in percent) in Finland and Emissions(in percent) in Jamaica?
Provide a succinct answer. 43.88. In the year 1994, what is the difference between the Emissions(in percent) in Finland and Emissions(in percent) in Romania?
Your answer should be compact. 12.51. In the year 1994, what is the difference between the Emissions(in percent) in Jamaica and Emissions(in percent) in Romania?
Your response must be concise. -31.38. In the year 1995, what is the difference between the Emissions(in percent) of Dominican Republic and Emissions(in percent) of Finland?
Offer a very short reply. -42.61. In the year 1995, what is the difference between the Emissions(in percent) in Dominican Republic and Emissions(in percent) in Jamaica?
Make the answer very short. 0.34. In the year 1995, what is the difference between the Emissions(in percent) in Dominican Republic and Emissions(in percent) in Romania?
Give a very brief answer. -29.08. In the year 1995, what is the difference between the Emissions(in percent) in Finland and Emissions(in percent) in Jamaica?
Ensure brevity in your answer.  42.94. In the year 1995, what is the difference between the Emissions(in percent) of Finland and Emissions(in percent) of Romania?
Your response must be concise. 13.53. In the year 1995, what is the difference between the Emissions(in percent) of Jamaica and Emissions(in percent) of Romania?
Provide a short and direct response. -29.41. In the year 1996, what is the difference between the Emissions(in percent) of Dominican Republic and Emissions(in percent) of Finland?
Ensure brevity in your answer.  -44.08. In the year 1996, what is the difference between the Emissions(in percent) of Dominican Republic and Emissions(in percent) of Jamaica?
Your answer should be compact. 0.31. In the year 1996, what is the difference between the Emissions(in percent) in Dominican Republic and Emissions(in percent) in Romania?
Give a very brief answer. -28.52. In the year 1996, what is the difference between the Emissions(in percent) of Finland and Emissions(in percent) of Jamaica?
Offer a very short reply. 44.39. In the year 1996, what is the difference between the Emissions(in percent) of Finland and Emissions(in percent) of Romania?
Your answer should be compact. 15.56. In the year 1996, what is the difference between the Emissions(in percent) of Jamaica and Emissions(in percent) of Romania?
Your response must be concise. -28.83. In the year 1997, what is the difference between the Emissions(in percent) of Dominican Republic and Emissions(in percent) of Finland?
Your answer should be very brief. -41.82. In the year 1997, what is the difference between the Emissions(in percent) in Dominican Republic and Emissions(in percent) in Jamaica?
Offer a very short reply. 0.37. In the year 1997, what is the difference between the Emissions(in percent) in Dominican Republic and Emissions(in percent) in Romania?
Your answer should be very brief. -29.01. In the year 1997, what is the difference between the Emissions(in percent) of Finland and Emissions(in percent) of Jamaica?
Offer a terse response. 42.19. In the year 1997, what is the difference between the Emissions(in percent) of Finland and Emissions(in percent) of Romania?
Provide a succinct answer. 12.81. In the year 1997, what is the difference between the Emissions(in percent) in Jamaica and Emissions(in percent) in Romania?
Give a very brief answer. -29.38. In the year 1998, what is the difference between the Emissions(in percent) of Dominican Republic and Emissions(in percent) of Finland?
Your answer should be compact. -33.46. In the year 1998, what is the difference between the Emissions(in percent) of Dominican Republic and Emissions(in percent) of Jamaica?
Your answer should be very brief. 1.98. In the year 1998, what is the difference between the Emissions(in percent) in Dominican Republic and Emissions(in percent) in Romania?
Ensure brevity in your answer.  -24.29. In the year 1998, what is the difference between the Emissions(in percent) in Finland and Emissions(in percent) in Jamaica?
Ensure brevity in your answer.  35.44. In the year 1998, what is the difference between the Emissions(in percent) in Finland and Emissions(in percent) in Romania?
Provide a succinct answer. 9.17. In the year 1998, what is the difference between the Emissions(in percent) of Jamaica and Emissions(in percent) of Romania?
Keep it short and to the point. -26.27. In the year 1999, what is the difference between the Emissions(in percent) in Dominican Republic and Emissions(in percent) in Finland?
Give a very brief answer. -33.92. In the year 1999, what is the difference between the Emissions(in percent) of Dominican Republic and Emissions(in percent) of Jamaica?
Give a very brief answer. 1.39. In the year 1999, what is the difference between the Emissions(in percent) in Dominican Republic and Emissions(in percent) in Romania?
Provide a short and direct response. -26.52. In the year 1999, what is the difference between the Emissions(in percent) of Finland and Emissions(in percent) of Jamaica?
Give a very brief answer. 35.31. In the year 1999, what is the difference between the Emissions(in percent) of Finland and Emissions(in percent) of Romania?
Your answer should be very brief. 7.41. In the year 1999, what is the difference between the Emissions(in percent) in Jamaica and Emissions(in percent) in Romania?
Provide a short and direct response. -27.9. In the year 2000, what is the difference between the Emissions(in percent) in Dominican Republic and Emissions(in percent) in Finland?
Provide a short and direct response. -36.67. In the year 2000, what is the difference between the Emissions(in percent) of Dominican Republic and Emissions(in percent) of Jamaica?
Your answer should be compact. -0.61. In the year 2000, what is the difference between the Emissions(in percent) of Dominican Republic and Emissions(in percent) of Romania?
Give a very brief answer. -31.17. In the year 2000, what is the difference between the Emissions(in percent) of Finland and Emissions(in percent) of Jamaica?
Provide a succinct answer. 36.06. In the year 2000, what is the difference between the Emissions(in percent) of Finland and Emissions(in percent) of Romania?
Your answer should be compact. 5.5. In the year 2000, what is the difference between the Emissions(in percent) of Jamaica and Emissions(in percent) of Romania?
Give a very brief answer. -30.56. What is the ratio of the Emissions(in percent) in Dominican Republic in 1993 to that in 1994?
Make the answer very short. 1.23. What is the ratio of the Emissions(in percent) in Finland in 1993 to that in 1994?
Make the answer very short. 0.92. What is the ratio of the Emissions(in percent) in Jamaica in 1993 to that in 1994?
Give a very brief answer. 1.08. What is the ratio of the Emissions(in percent) of Romania in 1993 to that in 1994?
Make the answer very short. 0.92. What is the ratio of the Emissions(in percent) of Dominican Republic in 1993 to that in 1995?
Your response must be concise. 1.47. What is the ratio of the Emissions(in percent) in Finland in 1993 to that in 1995?
Make the answer very short. 0.94. What is the ratio of the Emissions(in percent) of Jamaica in 1993 to that in 1995?
Offer a very short reply. 1.15. What is the ratio of the Emissions(in percent) in Romania in 1993 to that in 1995?
Your answer should be very brief. 0.98. What is the ratio of the Emissions(in percent) of Dominican Republic in 1993 to that in 1996?
Offer a terse response. 1.38. What is the ratio of the Emissions(in percent) in Finland in 1993 to that in 1996?
Ensure brevity in your answer.  0.91. What is the ratio of the Emissions(in percent) of Jamaica in 1993 to that in 1996?
Keep it short and to the point. 1.05. What is the ratio of the Emissions(in percent) in Dominican Republic in 1993 to that in 1997?
Make the answer very short. 1.32. What is the ratio of the Emissions(in percent) in Finland in 1993 to that in 1997?
Give a very brief answer. 0.95. What is the ratio of the Emissions(in percent) in Jamaica in 1993 to that in 1997?
Make the answer very short. 1.03. What is the ratio of the Emissions(in percent) in Romania in 1993 to that in 1997?
Make the answer very short. 0.98. What is the ratio of the Emissions(in percent) in Dominican Republic in 1993 to that in 1998?
Provide a short and direct response. 0.69. What is the ratio of the Emissions(in percent) of Finland in 1993 to that in 1998?
Offer a terse response. 1.12. What is the ratio of the Emissions(in percent) in Jamaica in 1993 to that in 1998?
Offer a terse response. 0.91. What is the ratio of the Emissions(in percent) of Romania in 1993 to that in 1998?
Your answer should be very brief. 1.08. What is the ratio of the Emissions(in percent) of Dominican Republic in 1993 to that in 1999?
Provide a succinct answer. 0.81. What is the ratio of the Emissions(in percent) of Finland in 1993 to that in 1999?
Ensure brevity in your answer.  1.12. What is the ratio of the Emissions(in percent) of Jamaica in 1993 to that in 1999?
Your answer should be very brief. 0.89. What is the ratio of the Emissions(in percent) of Romania in 1993 to that in 1999?
Your response must be concise. 1.02. What is the ratio of the Emissions(in percent) in Dominican Republic in 1993 to that in 2000?
Offer a very short reply. 2.18. What is the ratio of the Emissions(in percent) of Finland in 1993 to that in 2000?
Give a very brief answer. 1.1. What is the ratio of the Emissions(in percent) in Jamaica in 1993 to that in 2000?
Offer a very short reply. 0.94. What is the ratio of the Emissions(in percent) of Romania in 1993 to that in 2000?
Your response must be concise. 0.94. What is the ratio of the Emissions(in percent) in Dominican Republic in 1994 to that in 1995?
Your answer should be compact. 1.19. What is the ratio of the Emissions(in percent) of Finland in 1994 to that in 1995?
Provide a short and direct response. 1.02. What is the ratio of the Emissions(in percent) in Jamaica in 1994 to that in 1995?
Your answer should be very brief. 1.07. What is the ratio of the Emissions(in percent) of Romania in 1994 to that in 1995?
Offer a terse response. 1.07. What is the ratio of the Emissions(in percent) in Dominican Republic in 1994 to that in 1996?
Your answer should be very brief. 1.12. What is the ratio of the Emissions(in percent) in Jamaica in 1994 to that in 1996?
Provide a succinct answer. 0.98. What is the ratio of the Emissions(in percent) of Romania in 1994 to that in 1996?
Provide a short and direct response. 1.08. What is the ratio of the Emissions(in percent) of Dominican Republic in 1994 to that in 1997?
Keep it short and to the point. 1.07. What is the ratio of the Emissions(in percent) in Finland in 1994 to that in 1997?
Keep it short and to the point. 1.04. What is the ratio of the Emissions(in percent) in Jamaica in 1994 to that in 1997?
Offer a very short reply. 0.96. What is the ratio of the Emissions(in percent) of Romania in 1994 to that in 1997?
Ensure brevity in your answer.  1.06. What is the ratio of the Emissions(in percent) of Dominican Republic in 1994 to that in 1998?
Give a very brief answer. 0.56. What is the ratio of the Emissions(in percent) in Finland in 1994 to that in 1998?
Provide a short and direct response. 1.22. What is the ratio of the Emissions(in percent) in Jamaica in 1994 to that in 1998?
Your answer should be compact. 0.84. What is the ratio of the Emissions(in percent) in Romania in 1994 to that in 1998?
Provide a succinct answer. 1.17. What is the ratio of the Emissions(in percent) in Dominican Republic in 1994 to that in 1999?
Offer a very short reply. 0.66. What is the ratio of the Emissions(in percent) in Finland in 1994 to that in 1999?
Your answer should be compact. 1.22. What is the ratio of the Emissions(in percent) in Jamaica in 1994 to that in 1999?
Ensure brevity in your answer.  0.83. What is the ratio of the Emissions(in percent) in Romania in 1994 to that in 1999?
Your answer should be very brief. 1.11. What is the ratio of the Emissions(in percent) of Dominican Republic in 1994 to that in 2000?
Provide a succinct answer. 1.78. What is the ratio of the Emissions(in percent) of Finland in 1994 to that in 2000?
Your response must be concise. 1.2. What is the ratio of the Emissions(in percent) in Jamaica in 1994 to that in 2000?
Provide a succinct answer. 0.87. What is the ratio of the Emissions(in percent) in Romania in 1994 to that in 2000?
Ensure brevity in your answer.  1.02. What is the ratio of the Emissions(in percent) of Dominican Republic in 1995 to that in 1996?
Your answer should be very brief. 0.94. What is the ratio of the Emissions(in percent) in Finland in 1995 to that in 1996?
Provide a short and direct response. 0.97. What is the ratio of the Emissions(in percent) of Jamaica in 1995 to that in 1996?
Your response must be concise. 0.91. What is the ratio of the Emissions(in percent) of Romania in 1995 to that in 1996?
Give a very brief answer. 1.01. What is the ratio of the Emissions(in percent) in Dominican Republic in 1995 to that in 1997?
Give a very brief answer. 0.9. What is the ratio of the Emissions(in percent) in Finland in 1995 to that in 1997?
Your answer should be very brief. 1.01. What is the ratio of the Emissions(in percent) in Jamaica in 1995 to that in 1997?
Your answer should be compact. 0.89. What is the ratio of the Emissions(in percent) of Dominican Republic in 1995 to that in 1998?
Provide a short and direct response. 0.47. What is the ratio of the Emissions(in percent) of Finland in 1995 to that in 1998?
Give a very brief answer. 1.19. What is the ratio of the Emissions(in percent) in Jamaica in 1995 to that in 1998?
Make the answer very short. 0.79. What is the ratio of the Emissions(in percent) of Romania in 1995 to that in 1998?
Make the answer very short. 1.1. What is the ratio of the Emissions(in percent) in Dominican Republic in 1995 to that in 1999?
Offer a terse response. 0.55. What is the ratio of the Emissions(in percent) of Finland in 1995 to that in 1999?
Your answer should be very brief. 1.19. What is the ratio of the Emissions(in percent) in Jamaica in 1995 to that in 1999?
Offer a very short reply. 0.77. What is the ratio of the Emissions(in percent) in Romania in 1995 to that in 1999?
Your answer should be very brief. 1.04. What is the ratio of the Emissions(in percent) of Dominican Republic in 1995 to that in 2000?
Give a very brief answer. 1.49. What is the ratio of the Emissions(in percent) in Finland in 1995 to that in 2000?
Offer a very short reply. 1.17. What is the ratio of the Emissions(in percent) of Jamaica in 1995 to that in 2000?
Your response must be concise. 0.82. What is the ratio of the Emissions(in percent) in Romania in 1995 to that in 2000?
Your response must be concise. 0.95. What is the ratio of the Emissions(in percent) in Dominican Republic in 1996 to that in 1997?
Make the answer very short. 0.96. What is the ratio of the Emissions(in percent) in Finland in 1996 to that in 1997?
Offer a terse response. 1.05. What is the ratio of the Emissions(in percent) in Jamaica in 1996 to that in 1997?
Your answer should be compact. 0.98. What is the ratio of the Emissions(in percent) in Romania in 1996 to that in 1997?
Provide a short and direct response. 0.98. What is the ratio of the Emissions(in percent) of Dominican Republic in 1996 to that in 1998?
Your answer should be very brief. 0.5. What is the ratio of the Emissions(in percent) of Finland in 1996 to that in 1998?
Keep it short and to the point. 1.23. What is the ratio of the Emissions(in percent) in Jamaica in 1996 to that in 1998?
Offer a terse response. 0.86. What is the ratio of the Emissions(in percent) in Romania in 1996 to that in 1998?
Your answer should be compact. 1.08. What is the ratio of the Emissions(in percent) in Dominican Republic in 1996 to that in 1999?
Your answer should be very brief. 0.59. What is the ratio of the Emissions(in percent) of Finland in 1996 to that in 1999?
Ensure brevity in your answer.  1.24. What is the ratio of the Emissions(in percent) in Jamaica in 1996 to that in 1999?
Your response must be concise. 0.85. What is the ratio of the Emissions(in percent) of Romania in 1996 to that in 1999?
Keep it short and to the point. 1.02. What is the ratio of the Emissions(in percent) in Dominican Republic in 1996 to that in 2000?
Offer a terse response. 1.59. What is the ratio of the Emissions(in percent) of Finland in 1996 to that in 2000?
Provide a short and direct response. 1.21. What is the ratio of the Emissions(in percent) in Jamaica in 1996 to that in 2000?
Your answer should be compact. 0.9. What is the ratio of the Emissions(in percent) in Romania in 1996 to that in 2000?
Your response must be concise. 0.94. What is the ratio of the Emissions(in percent) in Dominican Republic in 1997 to that in 1998?
Your answer should be very brief. 0.53. What is the ratio of the Emissions(in percent) of Finland in 1997 to that in 1998?
Your answer should be compact. 1.17. What is the ratio of the Emissions(in percent) of Jamaica in 1997 to that in 1998?
Your answer should be very brief. 0.88. What is the ratio of the Emissions(in percent) in Romania in 1997 to that in 1998?
Your answer should be very brief. 1.1. What is the ratio of the Emissions(in percent) of Dominican Republic in 1997 to that in 1999?
Offer a very short reply. 0.62. What is the ratio of the Emissions(in percent) in Finland in 1997 to that in 1999?
Offer a terse response. 1.18. What is the ratio of the Emissions(in percent) of Jamaica in 1997 to that in 1999?
Provide a succinct answer. 0.87. What is the ratio of the Emissions(in percent) in Romania in 1997 to that in 1999?
Make the answer very short. 1.04. What is the ratio of the Emissions(in percent) of Dominican Republic in 1997 to that in 2000?
Keep it short and to the point. 1.66. What is the ratio of the Emissions(in percent) in Finland in 1997 to that in 2000?
Make the answer very short. 1.16. What is the ratio of the Emissions(in percent) of Jamaica in 1997 to that in 2000?
Provide a short and direct response. 0.91. What is the ratio of the Emissions(in percent) in Romania in 1997 to that in 2000?
Your answer should be very brief. 0.96. What is the ratio of the Emissions(in percent) in Dominican Republic in 1998 to that in 1999?
Give a very brief answer. 1.17. What is the ratio of the Emissions(in percent) in Finland in 1998 to that in 1999?
Your answer should be very brief. 1. What is the ratio of the Emissions(in percent) of Jamaica in 1998 to that in 1999?
Provide a succinct answer. 0.99. What is the ratio of the Emissions(in percent) in Romania in 1998 to that in 1999?
Provide a succinct answer. 0.94. What is the ratio of the Emissions(in percent) of Dominican Republic in 1998 to that in 2000?
Provide a succinct answer. 3.15. What is the ratio of the Emissions(in percent) in Finland in 1998 to that in 2000?
Offer a terse response. 0.99. What is the ratio of the Emissions(in percent) in Jamaica in 1998 to that in 2000?
Ensure brevity in your answer.  1.04. What is the ratio of the Emissions(in percent) in Romania in 1998 to that in 2000?
Provide a short and direct response. 0.87. What is the ratio of the Emissions(in percent) in Dominican Republic in 1999 to that in 2000?
Give a very brief answer. 2.69. What is the ratio of the Emissions(in percent) of Finland in 1999 to that in 2000?
Give a very brief answer. 0.98. What is the ratio of the Emissions(in percent) of Jamaica in 1999 to that in 2000?
Make the answer very short. 1.06. What is the ratio of the Emissions(in percent) of Romania in 1999 to that in 2000?
Your answer should be compact. 0.92. What is the difference between the highest and the second highest Emissions(in percent) in Dominican Republic?
Make the answer very short. 0.57. What is the difference between the highest and the second highest Emissions(in percent) of Finland?
Give a very brief answer. 0.55. What is the difference between the highest and the second highest Emissions(in percent) in Jamaica?
Keep it short and to the point. 0.03. What is the difference between the highest and the second highest Emissions(in percent) of Romania?
Your response must be concise. 0.58. What is the difference between the highest and the lowest Emissions(in percent) of Dominican Republic?
Your answer should be compact. 2.67. What is the difference between the highest and the lowest Emissions(in percent) of Finland?
Ensure brevity in your answer.  8.78. What is the difference between the highest and the lowest Emissions(in percent) in Jamaica?
Give a very brief answer. 0.44. What is the difference between the highest and the lowest Emissions(in percent) in Romania?
Ensure brevity in your answer.  4.8. 